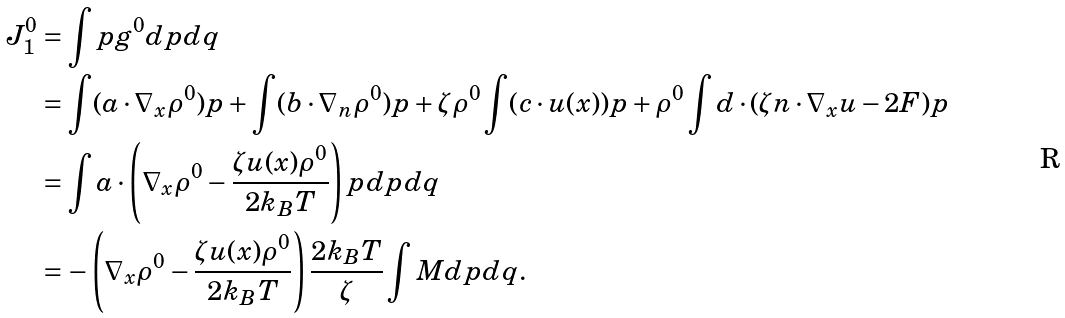Convert formula to latex. <formula><loc_0><loc_0><loc_500><loc_500>J _ { 1 } ^ { 0 } & = \int p g ^ { 0 } d p d q \\ & = \int ( a \cdot \nabla _ { x } \rho ^ { 0 } ) p + \int ( b \cdot \nabla _ { n } \rho ^ { 0 } ) p + \zeta \rho ^ { 0 } \int ( c \cdot u ( x ) ) p + \rho ^ { 0 } \int d \cdot ( \zeta n \cdot \nabla _ { x } u - 2 F ) p \\ & = \int a \cdot \left ( \nabla _ { x } \rho ^ { 0 } - \frac { \zeta u ( x ) \rho ^ { 0 } } { 2 k _ { B } T } \right ) p d p d q \\ & = - \left ( \nabla _ { x } \rho ^ { 0 } - \frac { \zeta u ( x ) \rho ^ { 0 } } { 2 k _ { B } T } \right ) \frac { 2 k _ { B } T } { \zeta } \int M d p d q .</formula> 